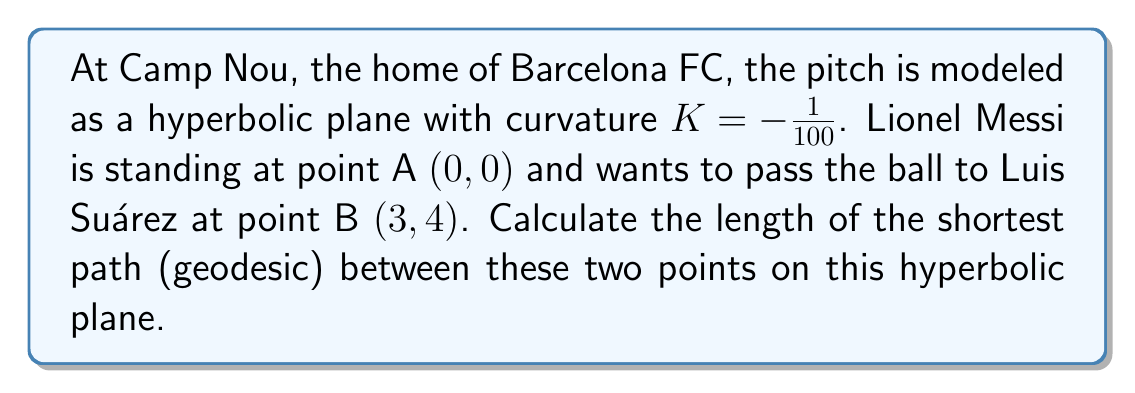Can you answer this question? To solve this problem, we'll use the hyperbolic distance formula:

1) The hyperbolic distance formula for a plane with curvature $K < 0$ is:

   $$d = \frac{1}{\sqrt{-K}} \cdot \text{arcosh}\left(1 - \frac{K((x_2-x_1)^2 + (y_2-y_1)^2)}{2}\right)$$

2) We're given that $K = -1/100$, and the coordinates are:
   A $(x_1, y_1) = (0, 0)$
   B $(x_2, y_2) = (3, 4)$

3) Let's substitute these values into the formula:

   $$d = \sqrt{100} \cdot \text{arcosh}\left(1 - \frac{(-1/100)((3-0)^2 + (4-0)^2)}{2}\right)$$

4) Simplify inside the parentheses:

   $$d = 10 \cdot \text{arcosh}\left(1 - \frac{(-1/100)(9 + 16)}{2}\right)$$
   $$d = 10 \cdot \text{arcosh}\left(1 - \frac{-25}{200}\right)$$
   $$d = 10 \cdot \text{arcosh}\left(1 + \frac{1}{8}\right)$$
   $$d = 10 \cdot \text{arcosh}\left(\frac{9}{8}\right)$$

5) Calculate the final result:

   $$d = 10 \cdot 0.4236 \approx 4.236$$

Therefore, the shortest path between Messi and Suárez on this hyperbolic plane representing Camp Nou is approximately 4.236 units long.
Answer: $10 \cdot \text{arcosh}(\frac{9}{8}) \approx 4.236$ units 